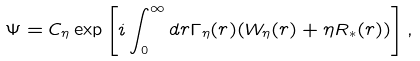<formula> <loc_0><loc_0><loc_500><loc_500>\Psi = C _ { \eta } \exp \left [ i \int _ { 0 } ^ { \infty } d r { \Gamma _ { \eta } } ( r ) ( { W _ { \eta } } ( r ) + \eta R _ { * } ( r ) ) \right ] ,</formula> 